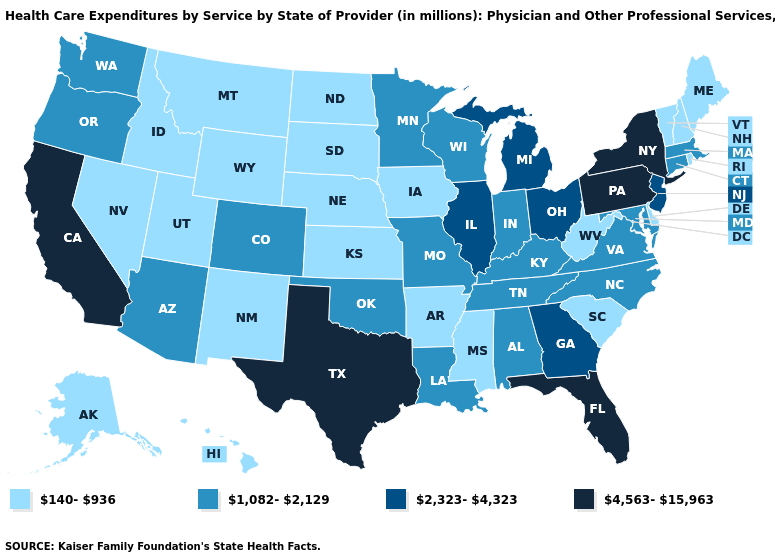What is the value of Michigan?
Quick response, please. 2,323-4,323. Name the states that have a value in the range 2,323-4,323?
Answer briefly. Georgia, Illinois, Michigan, New Jersey, Ohio. Name the states that have a value in the range 140-936?
Be succinct. Alaska, Arkansas, Delaware, Hawaii, Idaho, Iowa, Kansas, Maine, Mississippi, Montana, Nebraska, Nevada, New Hampshire, New Mexico, North Dakota, Rhode Island, South Carolina, South Dakota, Utah, Vermont, West Virginia, Wyoming. Name the states that have a value in the range 2,323-4,323?
Short answer required. Georgia, Illinois, Michigan, New Jersey, Ohio. Does Florida have the highest value in the South?
Give a very brief answer. Yes. What is the highest value in the West ?
Be succinct. 4,563-15,963. Which states have the lowest value in the MidWest?
Write a very short answer. Iowa, Kansas, Nebraska, North Dakota, South Dakota. What is the value of South Carolina?
Be succinct. 140-936. Does the first symbol in the legend represent the smallest category?
Give a very brief answer. Yes. Which states have the lowest value in the Northeast?
Keep it brief. Maine, New Hampshire, Rhode Island, Vermont. What is the lowest value in states that border Arizona?
Give a very brief answer. 140-936. Does Hawaii have the lowest value in the USA?
Concise answer only. Yes. Name the states that have a value in the range 1,082-2,129?
Keep it brief. Alabama, Arizona, Colorado, Connecticut, Indiana, Kentucky, Louisiana, Maryland, Massachusetts, Minnesota, Missouri, North Carolina, Oklahoma, Oregon, Tennessee, Virginia, Washington, Wisconsin. How many symbols are there in the legend?
Give a very brief answer. 4. What is the highest value in the USA?
Be succinct. 4,563-15,963. 